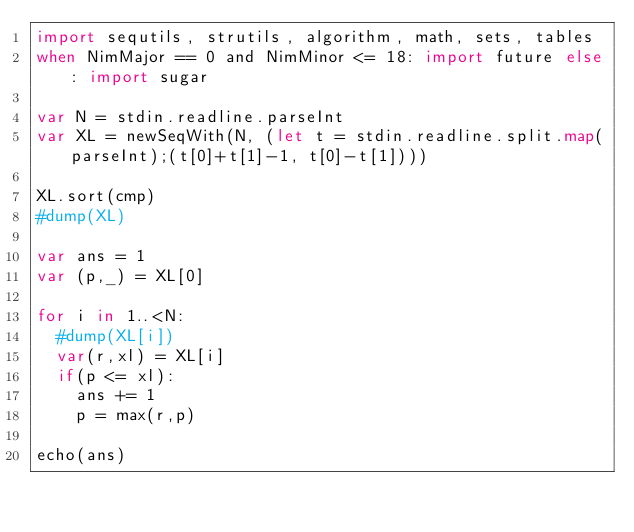<code> <loc_0><loc_0><loc_500><loc_500><_Nim_>import sequtils, strutils, algorithm, math, sets, tables
when NimMajor == 0 and NimMinor <= 18: import future else: import sugar

var N = stdin.readline.parseInt
var XL = newSeqWith(N, (let t = stdin.readline.split.map(parseInt);(t[0]+t[1]-1, t[0]-t[1])))

XL.sort(cmp)
#dump(XL)

var ans = 1
var (p,_) = XL[0]

for i in 1..<N:
  #dump(XL[i])
  var(r,xl) = XL[i]
  if(p <= xl):
    ans += 1
    p = max(r,p)

echo(ans)
</code> 